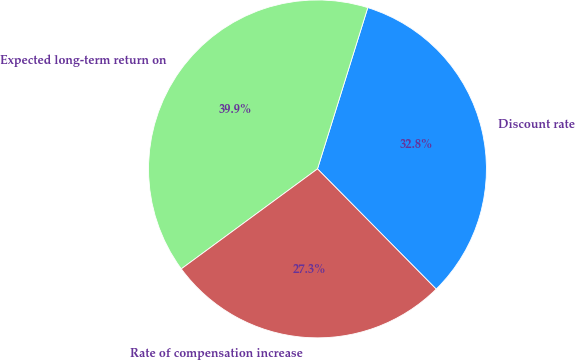Convert chart to OTSL. <chart><loc_0><loc_0><loc_500><loc_500><pie_chart><fcel>Discount rate<fcel>Expected long-term return on<fcel>Rate of compensation increase<nl><fcel>32.79%<fcel>39.89%<fcel>27.32%<nl></chart> 